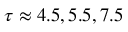<formula> <loc_0><loc_0><loc_500><loc_500>\tau \approx 4 . 5 , 5 . 5 , 7 . 5</formula> 